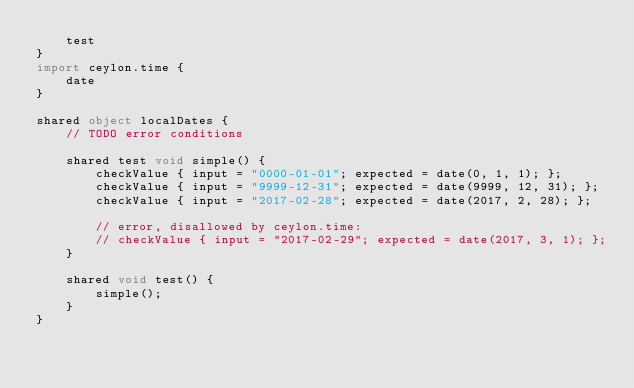Convert code to text. <code><loc_0><loc_0><loc_500><loc_500><_Ceylon_>    test
}
import ceylon.time {
    date
}

shared object localDates {
    // TODO error conditions

    shared test void simple() {
        checkValue { input = "0000-01-01"; expected = date(0, 1, 1); };
        checkValue { input = "9999-12-31"; expected = date(9999, 12, 31); };
        checkValue { input = "2017-02-28"; expected = date(2017, 2, 28); };

        // error, disallowed by ceylon.time:
        // checkValue { input = "2017-02-29"; expected = date(2017, 3, 1); };
    }

    shared void test() {
        simple();
    }
}
</code> 